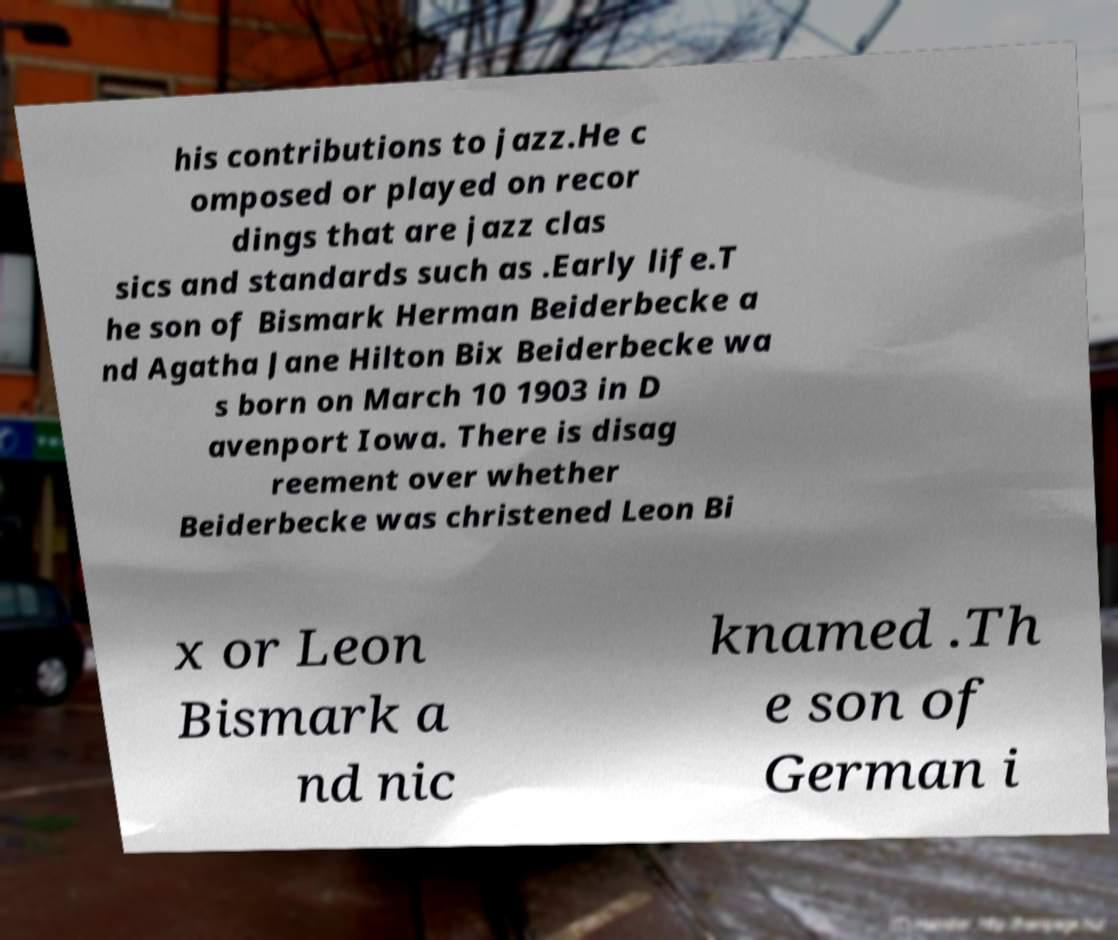Could you assist in decoding the text presented in this image and type it out clearly? his contributions to jazz.He c omposed or played on recor dings that are jazz clas sics and standards such as .Early life.T he son of Bismark Herman Beiderbecke a nd Agatha Jane Hilton Bix Beiderbecke wa s born on March 10 1903 in D avenport Iowa. There is disag reement over whether Beiderbecke was christened Leon Bi x or Leon Bismark a nd nic knamed .Th e son of German i 